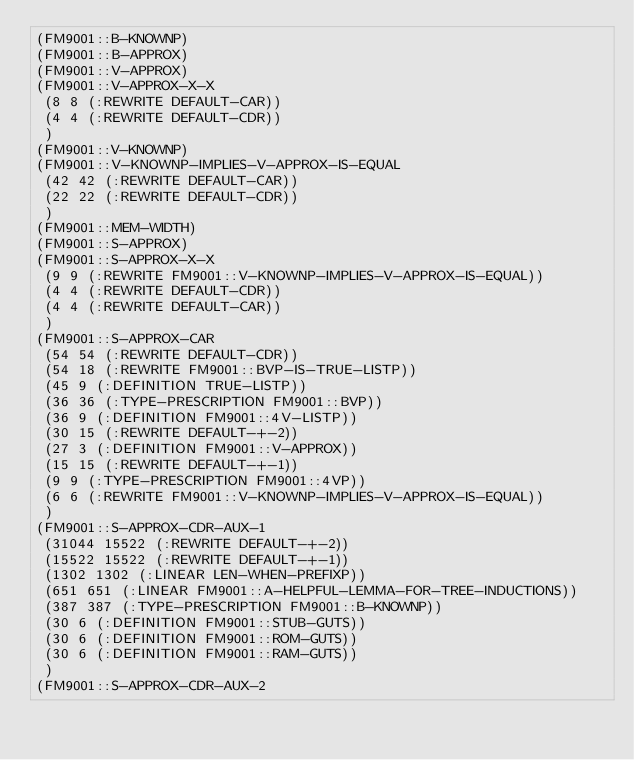<code> <loc_0><loc_0><loc_500><loc_500><_Lisp_>(FM9001::B-KNOWNP)
(FM9001::B-APPROX)
(FM9001::V-APPROX)
(FM9001::V-APPROX-X-X
 (8 8 (:REWRITE DEFAULT-CAR))
 (4 4 (:REWRITE DEFAULT-CDR))
 )
(FM9001::V-KNOWNP)
(FM9001::V-KNOWNP-IMPLIES-V-APPROX-IS-EQUAL
 (42 42 (:REWRITE DEFAULT-CAR))
 (22 22 (:REWRITE DEFAULT-CDR))
 )
(FM9001::MEM-WIDTH)
(FM9001::S-APPROX)
(FM9001::S-APPROX-X-X
 (9 9 (:REWRITE FM9001::V-KNOWNP-IMPLIES-V-APPROX-IS-EQUAL))
 (4 4 (:REWRITE DEFAULT-CDR))
 (4 4 (:REWRITE DEFAULT-CAR))
 )
(FM9001::S-APPROX-CAR
 (54 54 (:REWRITE DEFAULT-CDR))
 (54 18 (:REWRITE FM9001::BVP-IS-TRUE-LISTP))
 (45 9 (:DEFINITION TRUE-LISTP))
 (36 36 (:TYPE-PRESCRIPTION FM9001::BVP))
 (36 9 (:DEFINITION FM9001::4V-LISTP))
 (30 15 (:REWRITE DEFAULT-+-2))
 (27 3 (:DEFINITION FM9001::V-APPROX))
 (15 15 (:REWRITE DEFAULT-+-1))
 (9 9 (:TYPE-PRESCRIPTION FM9001::4VP))
 (6 6 (:REWRITE FM9001::V-KNOWNP-IMPLIES-V-APPROX-IS-EQUAL))
 )
(FM9001::S-APPROX-CDR-AUX-1
 (31044 15522 (:REWRITE DEFAULT-+-2))
 (15522 15522 (:REWRITE DEFAULT-+-1))
 (1302 1302 (:LINEAR LEN-WHEN-PREFIXP))
 (651 651 (:LINEAR FM9001::A-HELPFUL-LEMMA-FOR-TREE-INDUCTIONS))
 (387 387 (:TYPE-PRESCRIPTION FM9001::B-KNOWNP))
 (30 6 (:DEFINITION FM9001::STUB-GUTS))
 (30 6 (:DEFINITION FM9001::ROM-GUTS))
 (30 6 (:DEFINITION FM9001::RAM-GUTS))
 )
(FM9001::S-APPROX-CDR-AUX-2</code> 